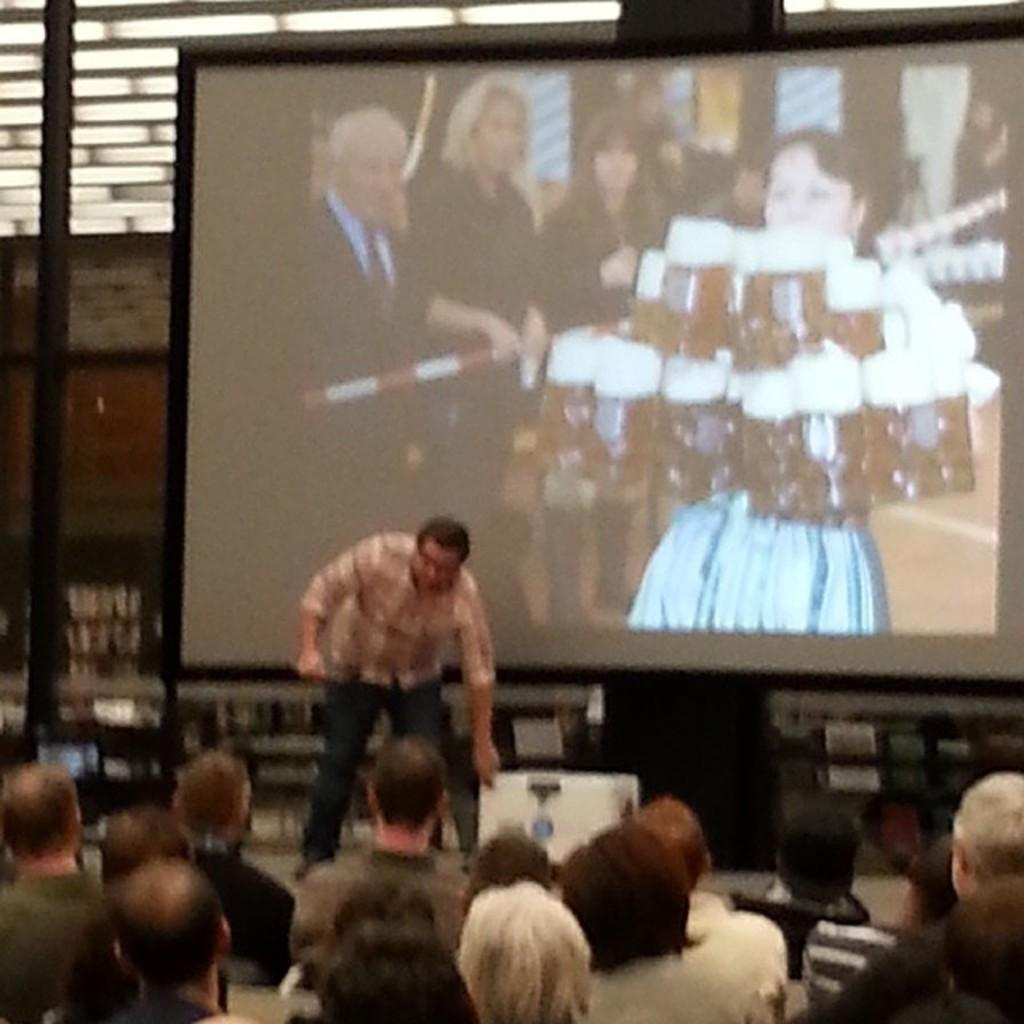How many people are in the image? There is a group of people in the image. Can you describe the position of the man in the image? There is a man standing on the floor in the image. What is in front of the group of people? There is a screen and a pole in front of the group of people. Are there any other objects in front of the group of people? Yes, there are some objects in front of the group of people. How many crates are being used for payment in the image? There is no mention of crates or payment in the image; it features a group of people with a man standing on the floor, a screen, a pole, and some objects in front of them. 